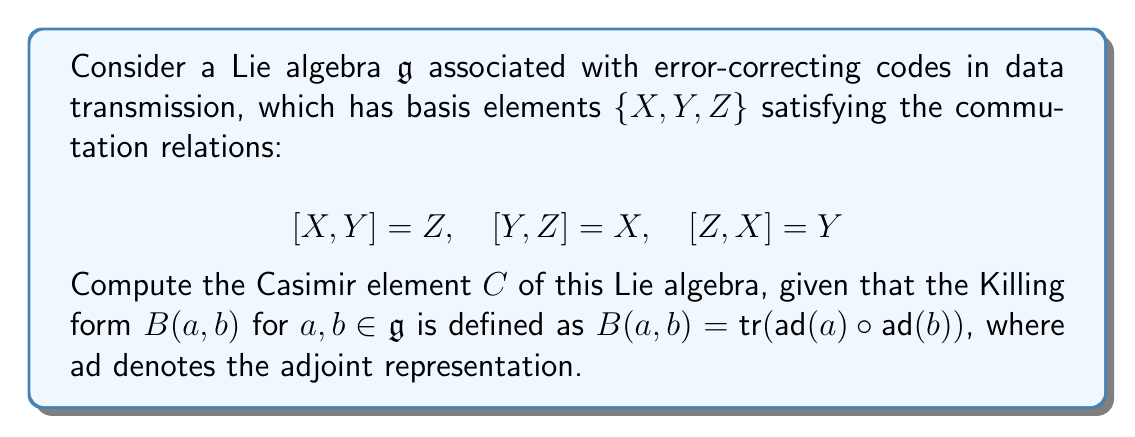Can you answer this question? To compute the Casimir element, we'll follow these steps:

1) First, we need to calculate the Killing form for each pair of basis elements. The Killing form is defined as $B(a,b) = \text{tr}(\text{ad}(a) \circ \text{ad}(b))$.

2) For each basis element, we can represent $\text{ad}(a)$ as a matrix:

   $\text{ad}(X) = \begin{pmatrix} 0 & 0 & -1 \\ 0 & 0 & 1 \\ 1 & -1 & 0 \end{pmatrix}$
   
   $\text{ad}(Y) = \begin{pmatrix} 0 & 0 & 1 \\ 0 & 0 & -1 \\ -1 & 1 & 0 \end{pmatrix}$
   
   $\text{ad}(Z) = \begin{pmatrix} 0 & -1 & 0 \\ 1 & 0 & 0 \\ 0 & 0 & 0 \end{pmatrix}$

3) Now, we can calculate the Killing form for each pair:

   $B(X,X) = B(Y,Y) = B(Z,Z) = \text{tr}(\text{ad}(X)^2) = 2$
   $B(X,Y) = B(Y,X) = B(Y,Z) = B(Z,Y) = B(Z,X) = B(X,Z) = 0$

4) The Casimir element is defined as $C = \sum_{i,j} B^{ij} e_i e_j$, where $B^{ij}$ is the inverse of the matrix representation of the Killing form, and $e_i$ are the basis elements.

5) The matrix representation of the Killing form is:

   $B = \begin{pmatrix} 2 & 0 & 0 \\ 0 & 2 & 0 \\ 0 & 0 & 2 \end{pmatrix}$

6) The inverse of this matrix is:

   $B^{-1} = \begin{pmatrix} 1/2 & 0 & 0 \\ 0 & 1/2 & 0 \\ 0 & 0 & 1/2 \end{pmatrix}$

7) Therefore, the Casimir element is:

   $C = \frac{1}{2}(X^2 + Y^2 + Z^2)$

This Casimir element is invariant under the action of the Lie algebra and can be used in the context of error-correcting codes to design robust encoding schemes that are resilient to certain types of transmission errors.
Answer: The Casimir element of the given Lie algebra is $C = \frac{1}{2}(X^2 + Y^2 + Z^2)$. 